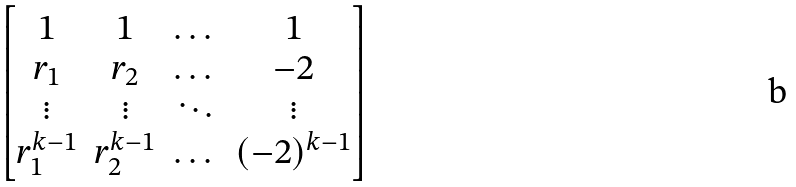<formula> <loc_0><loc_0><loc_500><loc_500>\begin{bmatrix} 1 & 1 & \dots & 1 \\ r _ { 1 } & r _ { 2 } & \dots & - 2 \\ \vdots & \vdots & \ddots & \vdots \\ r ^ { k - 1 } _ { 1 } & r ^ { k - 1 } _ { 2 } & \dots & ( - 2 ) ^ { k - 1 } \\ \end{bmatrix}</formula> 